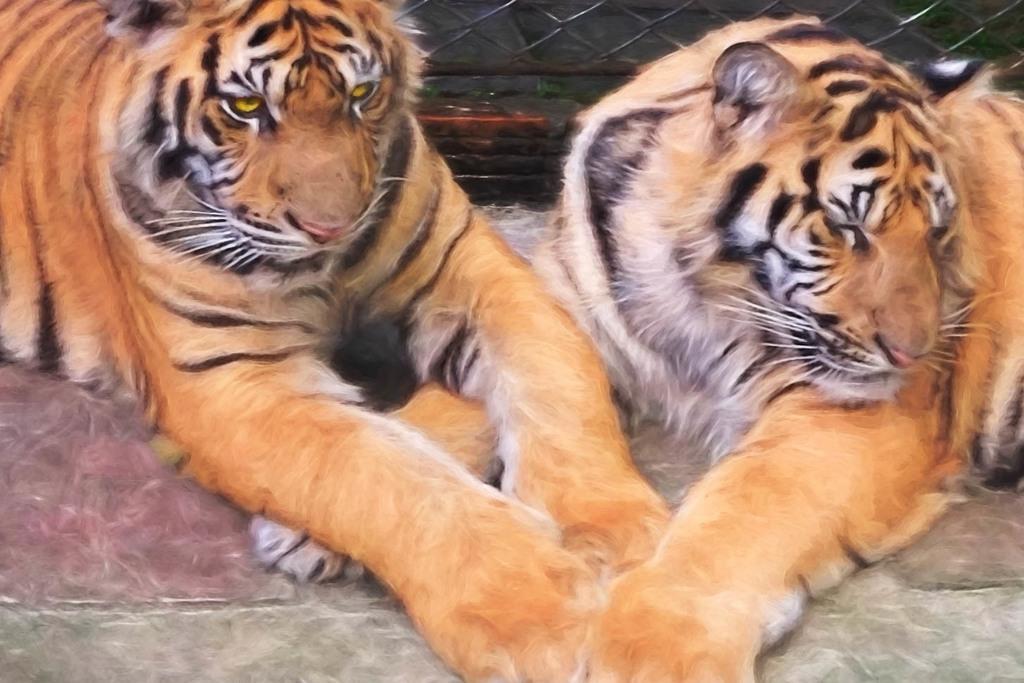Please provide a concise description of this image. In this picture, we see two tigers. In the background, we see a black color wall or a fence. This picture might be clicked in a zoo. 